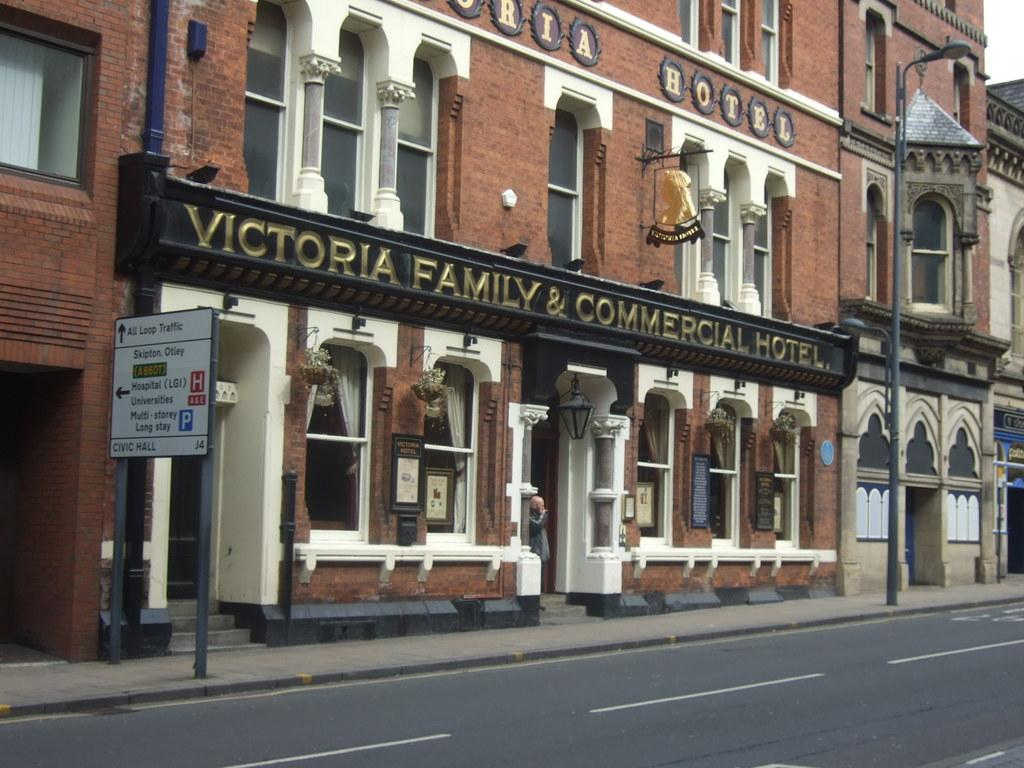What type of structures can be seen in the image? There are buildings in the image. What architectural features are visible on the buildings? There are windows, stairs, and a signboard visible on the buildings. What is the purpose of the pole in the image? The pole in the image is a light pole, which is used to hold lights. What objects are present for decorative purposes? There are flower pots in the image. Can you describe the person in the image? There is a person in the image, but no specific details about their appearance or actions are provided. What is the color of the sky in the image? The sky is white in color. What type of pest can be seen crawling on the signboard in the image? There is no pest visible on the signboard in the image. What type of grass is growing near the flower pots in the image? There is no grass present in the image; only flower pots are mentioned. 